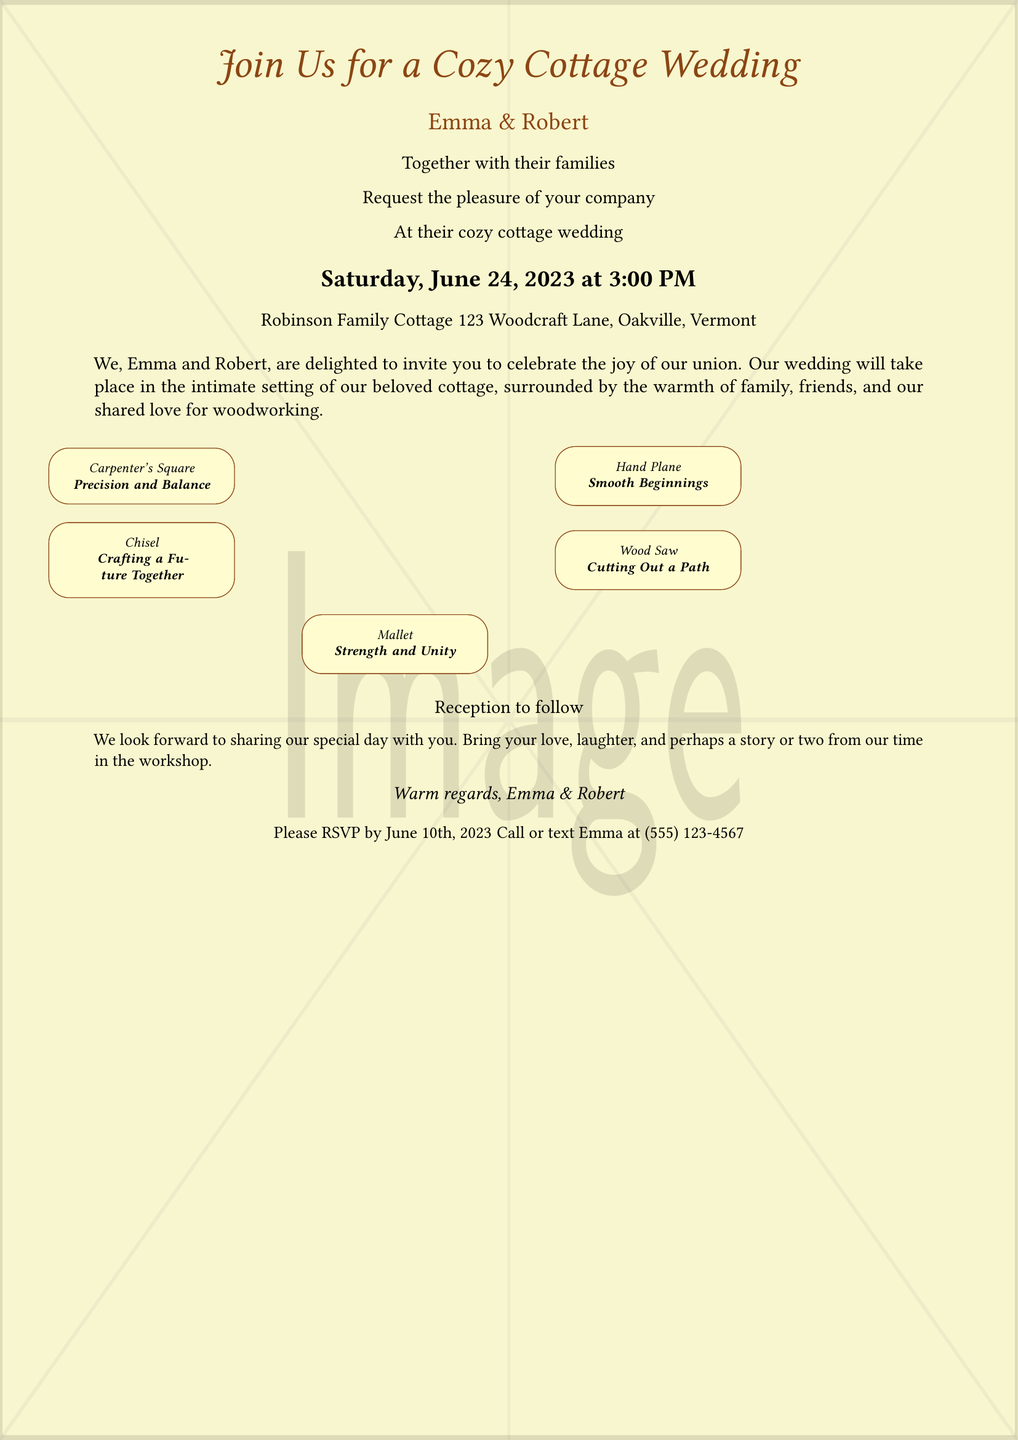What is the date of the wedding? The wedding date is specifically mentioned in the document as Saturday, June 24, 2023.
Answer: Saturday, June 24, 2023 Who are the couple getting married? The document states the names of the couple as Emma and Robert.
Answer: Emma and Robert Where is the wedding taking place? The location of the wedding is provided in the document, which indicates that it will be held at Robinson Family Cottage.
Answer: Robinson Family Cottage What should guests bring to the wedding? The document invites guests to bring their love, laughter, and perhaps a story from their time in the workshop.
Answer: Love, laughter, and stories What time does the wedding start? The beginning time of the wedding is stated as 3:00 PM.
Answer: 3:00 PM What color is used for the text? The primary color for the text in the document is wood brown.
Answer: Wood brown What is the RSVP date? The RSVP date is clearly noted in the document as June 10th, 2023.
Answer: June 10th, 2023 What tool is associated with "Crafting a Future Together"? The tool linked to "Crafting a Future Together" is the chisel, as mentioned in the toolbox section.
Answer: Chisel What is the theme of the wedding as suggested by the invitation? The invitation suggests a cozy and intimate theme focused on family and woodworking elements.
Answer: Cozy cottage wedding 